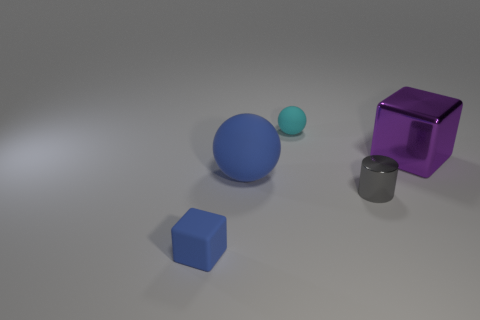What number of other things are the same material as the tiny cube?
Your answer should be compact. 2. Is the material of the big blue sphere the same as the small cyan sphere?
Your response must be concise. Yes. How many other objects are there of the same size as the gray cylinder?
Your response must be concise. 2. There is a sphere that is in front of the big thing to the right of the tiny ball; what is its size?
Provide a short and direct response. Large. There is a large thing that is in front of the cube to the right of the small matte thing that is in front of the big purple object; what is its color?
Your answer should be compact. Blue. There is a object that is both in front of the blue sphere and on the left side of the gray metallic thing; how big is it?
Provide a short and direct response. Small. What number of other objects are there of the same shape as the small gray object?
Ensure brevity in your answer.  0. What number of blocks are either small things or big purple objects?
Your answer should be compact. 2. Is there a big blue rubber thing behind the small rubber thing that is in front of the big block on the right side of the gray shiny object?
Your response must be concise. Yes. What is the color of the small rubber object that is the same shape as the big purple shiny thing?
Offer a terse response. Blue. 